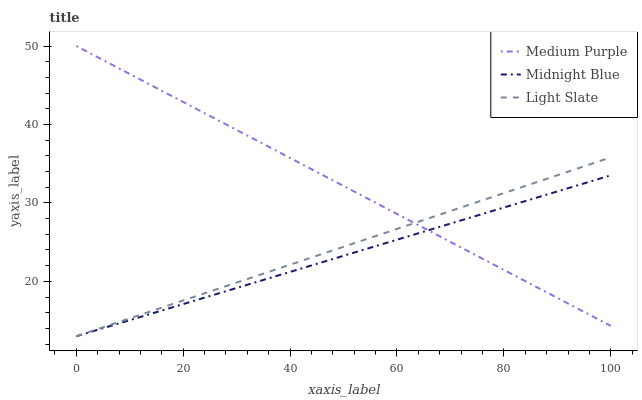Does Light Slate have the minimum area under the curve?
Answer yes or no. No. Does Light Slate have the maximum area under the curve?
Answer yes or no. No. Is Light Slate the smoothest?
Answer yes or no. No. Is Light Slate the roughest?
Answer yes or no. No. Does Light Slate have the highest value?
Answer yes or no. No. 